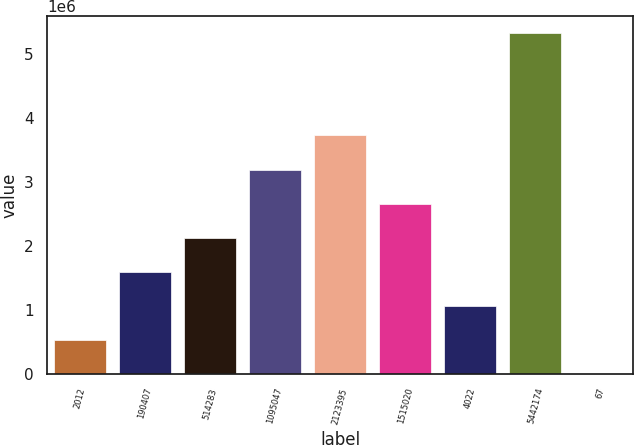<chart> <loc_0><loc_0><loc_500><loc_500><bar_chart><fcel>2012<fcel>190407<fcel>514283<fcel>1095047<fcel>2123395<fcel>1515020<fcel>4022<fcel>5442174<fcel>67<nl><fcel>532871<fcel>1.5986e+06<fcel>2.13147e+06<fcel>3.1972e+06<fcel>3.73006e+06<fcel>2.66433e+06<fcel>1.06574e+06<fcel>5.32866e+06<fcel>5.9<nl></chart> 